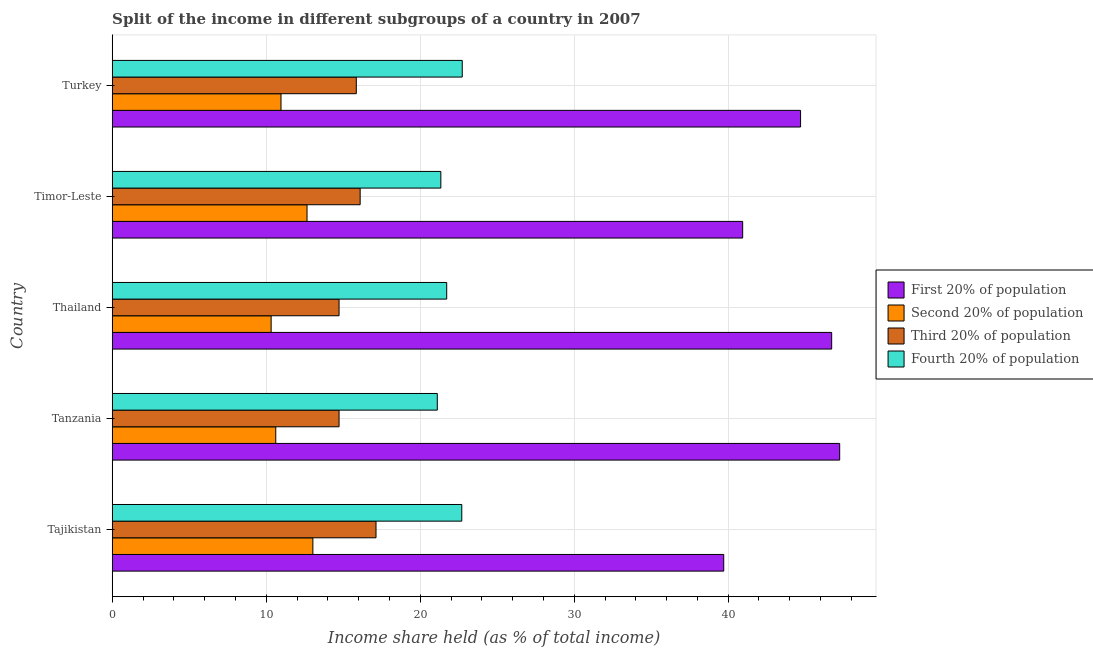Are the number of bars on each tick of the Y-axis equal?
Your response must be concise. Yes. How many bars are there on the 5th tick from the top?
Make the answer very short. 4. How many bars are there on the 1st tick from the bottom?
Ensure brevity in your answer.  4. What is the label of the 2nd group of bars from the top?
Your response must be concise. Timor-Leste. What is the share of the income held by fourth 20% of the population in Turkey?
Your answer should be very brief. 22.73. Across all countries, what is the maximum share of the income held by third 20% of the population?
Give a very brief answer. 17.13. Across all countries, what is the minimum share of the income held by third 20% of the population?
Offer a very short reply. 14.73. In which country was the share of the income held by second 20% of the population maximum?
Your answer should be very brief. Tajikistan. In which country was the share of the income held by second 20% of the population minimum?
Provide a short and direct response. Thailand. What is the total share of the income held by third 20% of the population in the graph?
Make the answer very short. 78.54. What is the difference between the share of the income held by third 20% of the population in Tajikistan and that in Thailand?
Offer a very short reply. 2.4. What is the difference between the share of the income held by second 20% of the population in Turkey and the share of the income held by first 20% of the population in Tajikistan?
Offer a terse response. -28.75. What is the average share of the income held by first 20% of the population per country?
Your answer should be compact. 43.86. What is the difference between the share of the income held by second 20% of the population and share of the income held by fourth 20% of the population in Tajikistan?
Your answer should be compact. -9.67. In how many countries, is the share of the income held by fourth 20% of the population greater than 46 %?
Offer a terse response. 0. What is the ratio of the share of the income held by fourth 20% of the population in Tanzania to that in Turkey?
Your response must be concise. 0.93. Is the difference between the share of the income held by second 20% of the population in Tanzania and Turkey greater than the difference between the share of the income held by third 20% of the population in Tanzania and Turkey?
Give a very brief answer. Yes. What is the difference between the highest and the lowest share of the income held by first 20% of the population?
Offer a terse response. 7.53. In how many countries, is the share of the income held by first 20% of the population greater than the average share of the income held by first 20% of the population taken over all countries?
Offer a very short reply. 3. Is the sum of the share of the income held by third 20% of the population in Tajikistan and Timor-Leste greater than the maximum share of the income held by first 20% of the population across all countries?
Your response must be concise. No. What does the 1st bar from the top in Turkey represents?
Your response must be concise. Fourth 20% of population. What does the 1st bar from the bottom in Thailand represents?
Give a very brief answer. First 20% of population. Is it the case that in every country, the sum of the share of the income held by first 20% of the population and share of the income held by second 20% of the population is greater than the share of the income held by third 20% of the population?
Make the answer very short. Yes. How many bars are there?
Keep it short and to the point. 20. Are all the bars in the graph horizontal?
Provide a short and direct response. Yes. What is the difference between two consecutive major ticks on the X-axis?
Offer a very short reply. 10. Are the values on the major ticks of X-axis written in scientific E-notation?
Offer a very short reply. No. How are the legend labels stacked?
Offer a terse response. Vertical. What is the title of the graph?
Your response must be concise. Split of the income in different subgroups of a country in 2007. Does "Italy" appear as one of the legend labels in the graph?
Your response must be concise. No. What is the label or title of the X-axis?
Your answer should be very brief. Income share held (as % of total income). What is the Income share held (as % of total income) of First 20% of population in Tajikistan?
Your answer should be very brief. 39.71. What is the Income share held (as % of total income) of Second 20% of population in Tajikistan?
Give a very brief answer. 13.03. What is the Income share held (as % of total income) of Third 20% of population in Tajikistan?
Make the answer very short. 17.13. What is the Income share held (as % of total income) in Fourth 20% of population in Tajikistan?
Provide a short and direct response. 22.7. What is the Income share held (as % of total income) of First 20% of population in Tanzania?
Give a very brief answer. 47.24. What is the Income share held (as % of total income) in Second 20% of population in Tanzania?
Your answer should be compact. 10.62. What is the Income share held (as % of total income) of Third 20% of population in Tanzania?
Your answer should be very brief. 14.73. What is the Income share held (as % of total income) of Fourth 20% of population in Tanzania?
Keep it short and to the point. 21.11. What is the Income share held (as % of total income) in First 20% of population in Thailand?
Ensure brevity in your answer.  46.72. What is the Income share held (as % of total income) in Second 20% of population in Thailand?
Your answer should be very brief. 10.32. What is the Income share held (as % of total income) of Third 20% of population in Thailand?
Make the answer very short. 14.73. What is the Income share held (as % of total income) of Fourth 20% of population in Thailand?
Offer a very short reply. 21.72. What is the Income share held (as % of total income) in First 20% of population in Timor-Leste?
Your answer should be very brief. 40.94. What is the Income share held (as % of total income) of Second 20% of population in Timor-Leste?
Give a very brief answer. 12.65. What is the Income share held (as % of total income) in Third 20% of population in Timor-Leste?
Provide a short and direct response. 16.1. What is the Income share held (as % of total income) of Fourth 20% of population in Timor-Leste?
Keep it short and to the point. 21.34. What is the Income share held (as % of total income) in First 20% of population in Turkey?
Ensure brevity in your answer.  44.7. What is the Income share held (as % of total income) in Second 20% of population in Turkey?
Offer a very short reply. 10.96. What is the Income share held (as % of total income) of Third 20% of population in Turkey?
Your answer should be compact. 15.85. What is the Income share held (as % of total income) in Fourth 20% of population in Turkey?
Make the answer very short. 22.73. Across all countries, what is the maximum Income share held (as % of total income) of First 20% of population?
Provide a succinct answer. 47.24. Across all countries, what is the maximum Income share held (as % of total income) of Second 20% of population?
Ensure brevity in your answer.  13.03. Across all countries, what is the maximum Income share held (as % of total income) of Third 20% of population?
Your answer should be compact. 17.13. Across all countries, what is the maximum Income share held (as % of total income) of Fourth 20% of population?
Provide a succinct answer. 22.73. Across all countries, what is the minimum Income share held (as % of total income) in First 20% of population?
Give a very brief answer. 39.71. Across all countries, what is the minimum Income share held (as % of total income) of Second 20% of population?
Your answer should be very brief. 10.32. Across all countries, what is the minimum Income share held (as % of total income) in Third 20% of population?
Ensure brevity in your answer.  14.73. Across all countries, what is the minimum Income share held (as % of total income) of Fourth 20% of population?
Provide a short and direct response. 21.11. What is the total Income share held (as % of total income) in First 20% of population in the graph?
Give a very brief answer. 219.31. What is the total Income share held (as % of total income) of Second 20% of population in the graph?
Your response must be concise. 57.58. What is the total Income share held (as % of total income) in Third 20% of population in the graph?
Provide a succinct answer. 78.54. What is the total Income share held (as % of total income) in Fourth 20% of population in the graph?
Offer a terse response. 109.6. What is the difference between the Income share held (as % of total income) in First 20% of population in Tajikistan and that in Tanzania?
Provide a succinct answer. -7.53. What is the difference between the Income share held (as % of total income) in Second 20% of population in Tajikistan and that in Tanzania?
Offer a very short reply. 2.41. What is the difference between the Income share held (as % of total income) in Fourth 20% of population in Tajikistan and that in Tanzania?
Offer a very short reply. 1.59. What is the difference between the Income share held (as % of total income) in First 20% of population in Tajikistan and that in Thailand?
Your answer should be very brief. -7.01. What is the difference between the Income share held (as % of total income) in Second 20% of population in Tajikistan and that in Thailand?
Offer a very short reply. 2.71. What is the difference between the Income share held (as % of total income) of Fourth 20% of population in Tajikistan and that in Thailand?
Your answer should be compact. 0.98. What is the difference between the Income share held (as % of total income) in First 20% of population in Tajikistan and that in Timor-Leste?
Your response must be concise. -1.23. What is the difference between the Income share held (as % of total income) in Second 20% of population in Tajikistan and that in Timor-Leste?
Offer a very short reply. 0.38. What is the difference between the Income share held (as % of total income) of Third 20% of population in Tajikistan and that in Timor-Leste?
Keep it short and to the point. 1.03. What is the difference between the Income share held (as % of total income) of Fourth 20% of population in Tajikistan and that in Timor-Leste?
Provide a succinct answer. 1.36. What is the difference between the Income share held (as % of total income) of First 20% of population in Tajikistan and that in Turkey?
Provide a short and direct response. -4.99. What is the difference between the Income share held (as % of total income) in Second 20% of population in Tajikistan and that in Turkey?
Your answer should be compact. 2.07. What is the difference between the Income share held (as % of total income) of Third 20% of population in Tajikistan and that in Turkey?
Make the answer very short. 1.28. What is the difference between the Income share held (as % of total income) of Fourth 20% of population in Tajikistan and that in Turkey?
Ensure brevity in your answer.  -0.03. What is the difference between the Income share held (as % of total income) of First 20% of population in Tanzania and that in Thailand?
Make the answer very short. 0.52. What is the difference between the Income share held (as % of total income) in Fourth 20% of population in Tanzania and that in Thailand?
Your answer should be compact. -0.61. What is the difference between the Income share held (as % of total income) of Second 20% of population in Tanzania and that in Timor-Leste?
Keep it short and to the point. -2.03. What is the difference between the Income share held (as % of total income) of Third 20% of population in Tanzania and that in Timor-Leste?
Offer a terse response. -1.37. What is the difference between the Income share held (as % of total income) of Fourth 20% of population in Tanzania and that in Timor-Leste?
Provide a succinct answer. -0.23. What is the difference between the Income share held (as % of total income) of First 20% of population in Tanzania and that in Turkey?
Your response must be concise. 2.54. What is the difference between the Income share held (as % of total income) in Second 20% of population in Tanzania and that in Turkey?
Give a very brief answer. -0.34. What is the difference between the Income share held (as % of total income) of Third 20% of population in Tanzania and that in Turkey?
Your answer should be compact. -1.12. What is the difference between the Income share held (as % of total income) of Fourth 20% of population in Tanzania and that in Turkey?
Make the answer very short. -1.62. What is the difference between the Income share held (as % of total income) in First 20% of population in Thailand and that in Timor-Leste?
Provide a succinct answer. 5.78. What is the difference between the Income share held (as % of total income) of Second 20% of population in Thailand and that in Timor-Leste?
Your response must be concise. -2.33. What is the difference between the Income share held (as % of total income) of Third 20% of population in Thailand and that in Timor-Leste?
Give a very brief answer. -1.37. What is the difference between the Income share held (as % of total income) in Fourth 20% of population in Thailand and that in Timor-Leste?
Your response must be concise. 0.38. What is the difference between the Income share held (as % of total income) of First 20% of population in Thailand and that in Turkey?
Ensure brevity in your answer.  2.02. What is the difference between the Income share held (as % of total income) of Second 20% of population in Thailand and that in Turkey?
Your answer should be very brief. -0.64. What is the difference between the Income share held (as % of total income) in Third 20% of population in Thailand and that in Turkey?
Offer a terse response. -1.12. What is the difference between the Income share held (as % of total income) of Fourth 20% of population in Thailand and that in Turkey?
Keep it short and to the point. -1.01. What is the difference between the Income share held (as % of total income) in First 20% of population in Timor-Leste and that in Turkey?
Your response must be concise. -3.76. What is the difference between the Income share held (as % of total income) in Second 20% of population in Timor-Leste and that in Turkey?
Keep it short and to the point. 1.69. What is the difference between the Income share held (as % of total income) in Third 20% of population in Timor-Leste and that in Turkey?
Your response must be concise. 0.25. What is the difference between the Income share held (as % of total income) of Fourth 20% of population in Timor-Leste and that in Turkey?
Offer a terse response. -1.39. What is the difference between the Income share held (as % of total income) of First 20% of population in Tajikistan and the Income share held (as % of total income) of Second 20% of population in Tanzania?
Offer a terse response. 29.09. What is the difference between the Income share held (as % of total income) of First 20% of population in Tajikistan and the Income share held (as % of total income) of Third 20% of population in Tanzania?
Your answer should be very brief. 24.98. What is the difference between the Income share held (as % of total income) in Second 20% of population in Tajikistan and the Income share held (as % of total income) in Third 20% of population in Tanzania?
Your answer should be compact. -1.7. What is the difference between the Income share held (as % of total income) in Second 20% of population in Tajikistan and the Income share held (as % of total income) in Fourth 20% of population in Tanzania?
Your answer should be compact. -8.08. What is the difference between the Income share held (as % of total income) in Third 20% of population in Tajikistan and the Income share held (as % of total income) in Fourth 20% of population in Tanzania?
Offer a terse response. -3.98. What is the difference between the Income share held (as % of total income) in First 20% of population in Tajikistan and the Income share held (as % of total income) in Second 20% of population in Thailand?
Your response must be concise. 29.39. What is the difference between the Income share held (as % of total income) of First 20% of population in Tajikistan and the Income share held (as % of total income) of Third 20% of population in Thailand?
Provide a short and direct response. 24.98. What is the difference between the Income share held (as % of total income) in First 20% of population in Tajikistan and the Income share held (as % of total income) in Fourth 20% of population in Thailand?
Provide a short and direct response. 17.99. What is the difference between the Income share held (as % of total income) of Second 20% of population in Tajikistan and the Income share held (as % of total income) of Fourth 20% of population in Thailand?
Make the answer very short. -8.69. What is the difference between the Income share held (as % of total income) of Third 20% of population in Tajikistan and the Income share held (as % of total income) of Fourth 20% of population in Thailand?
Keep it short and to the point. -4.59. What is the difference between the Income share held (as % of total income) of First 20% of population in Tajikistan and the Income share held (as % of total income) of Second 20% of population in Timor-Leste?
Make the answer very short. 27.06. What is the difference between the Income share held (as % of total income) in First 20% of population in Tajikistan and the Income share held (as % of total income) in Third 20% of population in Timor-Leste?
Provide a succinct answer. 23.61. What is the difference between the Income share held (as % of total income) of First 20% of population in Tajikistan and the Income share held (as % of total income) of Fourth 20% of population in Timor-Leste?
Your response must be concise. 18.37. What is the difference between the Income share held (as % of total income) of Second 20% of population in Tajikistan and the Income share held (as % of total income) of Third 20% of population in Timor-Leste?
Provide a succinct answer. -3.07. What is the difference between the Income share held (as % of total income) in Second 20% of population in Tajikistan and the Income share held (as % of total income) in Fourth 20% of population in Timor-Leste?
Your answer should be compact. -8.31. What is the difference between the Income share held (as % of total income) in Third 20% of population in Tajikistan and the Income share held (as % of total income) in Fourth 20% of population in Timor-Leste?
Keep it short and to the point. -4.21. What is the difference between the Income share held (as % of total income) in First 20% of population in Tajikistan and the Income share held (as % of total income) in Second 20% of population in Turkey?
Give a very brief answer. 28.75. What is the difference between the Income share held (as % of total income) in First 20% of population in Tajikistan and the Income share held (as % of total income) in Third 20% of population in Turkey?
Give a very brief answer. 23.86. What is the difference between the Income share held (as % of total income) in First 20% of population in Tajikistan and the Income share held (as % of total income) in Fourth 20% of population in Turkey?
Your answer should be compact. 16.98. What is the difference between the Income share held (as % of total income) of Second 20% of population in Tajikistan and the Income share held (as % of total income) of Third 20% of population in Turkey?
Make the answer very short. -2.82. What is the difference between the Income share held (as % of total income) of Second 20% of population in Tajikistan and the Income share held (as % of total income) of Fourth 20% of population in Turkey?
Ensure brevity in your answer.  -9.7. What is the difference between the Income share held (as % of total income) in First 20% of population in Tanzania and the Income share held (as % of total income) in Second 20% of population in Thailand?
Your answer should be compact. 36.92. What is the difference between the Income share held (as % of total income) in First 20% of population in Tanzania and the Income share held (as % of total income) in Third 20% of population in Thailand?
Your answer should be very brief. 32.51. What is the difference between the Income share held (as % of total income) of First 20% of population in Tanzania and the Income share held (as % of total income) of Fourth 20% of population in Thailand?
Provide a short and direct response. 25.52. What is the difference between the Income share held (as % of total income) in Second 20% of population in Tanzania and the Income share held (as % of total income) in Third 20% of population in Thailand?
Ensure brevity in your answer.  -4.11. What is the difference between the Income share held (as % of total income) in Third 20% of population in Tanzania and the Income share held (as % of total income) in Fourth 20% of population in Thailand?
Offer a terse response. -6.99. What is the difference between the Income share held (as % of total income) of First 20% of population in Tanzania and the Income share held (as % of total income) of Second 20% of population in Timor-Leste?
Your answer should be compact. 34.59. What is the difference between the Income share held (as % of total income) in First 20% of population in Tanzania and the Income share held (as % of total income) in Third 20% of population in Timor-Leste?
Offer a very short reply. 31.14. What is the difference between the Income share held (as % of total income) of First 20% of population in Tanzania and the Income share held (as % of total income) of Fourth 20% of population in Timor-Leste?
Keep it short and to the point. 25.9. What is the difference between the Income share held (as % of total income) of Second 20% of population in Tanzania and the Income share held (as % of total income) of Third 20% of population in Timor-Leste?
Offer a terse response. -5.48. What is the difference between the Income share held (as % of total income) of Second 20% of population in Tanzania and the Income share held (as % of total income) of Fourth 20% of population in Timor-Leste?
Your answer should be compact. -10.72. What is the difference between the Income share held (as % of total income) in Third 20% of population in Tanzania and the Income share held (as % of total income) in Fourth 20% of population in Timor-Leste?
Ensure brevity in your answer.  -6.61. What is the difference between the Income share held (as % of total income) in First 20% of population in Tanzania and the Income share held (as % of total income) in Second 20% of population in Turkey?
Give a very brief answer. 36.28. What is the difference between the Income share held (as % of total income) of First 20% of population in Tanzania and the Income share held (as % of total income) of Third 20% of population in Turkey?
Offer a terse response. 31.39. What is the difference between the Income share held (as % of total income) of First 20% of population in Tanzania and the Income share held (as % of total income) of Fourth 20% of population in Turkey?
Provide a short and direct response. 24.51. What is the difference between the Income share held (as % of total income) of Second 20% of population in Tanzania and the Income share held (as % of total income) of Third 20% of population in Turkey?
Your response must be concise. -5.23. What is the difference between the Income share held (as % of total income) in Second 20% of population in Tanzania and the Income share held (as % of total income) in Fourth 20% of population in Turkey?
Provide a succinct answer. -12.11. What is the difference between the Income share held (as % of total income) in First 20% of population in Thailand and the Income share held (as % of total income) in Second 20% of population in Timor-Leste?
Your answer should be compact. 34.07. What is the difference between the Income share held (as % of total income) of First 20% of population in Thailand and the Income share held (as % of total income) of Third 20% of population in Timor-Leste?
Your response must be concise. 30.62. What is the difference between the Income share held (as % of total income) in First 20% of population in Thailand and the Income share held (as % of total income) in Fourth 20% of population in Timor-Leste?
Keep it short and to the point. 25.38. What is the difference between the Income share held (as % of total income) in Second 20% of population in Thailand and the Income share held (as % of total income) in Third 20% of population in Timor-Leste?
Offer a terse response. -5.78. What is the difference between the Income share held (as % of total income) of Second 20% of population in Thailand and the Income share held (as % of total income) of Fourth 20% of population in Timor-Leste?
Your response must be concise. -11.02. What is the difference between the Income share held (as % of total income) of Third 20% of population in Thailand and the Income share held (as % of total income) of Fourth 20% of population in Timor-Leste?
Your response must be concise. -6.61. What is the difference between the Income share held (as % of total income) of First 20% of population in Thailand and the Income share held (as % of total income) of Second 20% of population in Turkey?
Keep it short and to the point. 35.76. What is the difference between the Income share held (as % of total income) in First 20% of population in Thailand and the Income share held (as % of total income) in Third 20% of population in Turkey?
Provide a succinct answer. 30.87. What is the difference between the Income share held (as % of total income) in First 20% of population in Thailand and the Income share held (as % of total income) in Fourth 20% of population in Turkey?
Offer a terse response. 23.99. What is the difference between the Income share held (as % of total income) of Second 20% of population in Thailand and the Income share held (as % of total income) of Third 20% of population in Turkey?
Your response must be concise. -5.53. What is the difference between the Income share held (as % of total income) in Second 20% of population in Thailand and the Income share held (as % of total income) in Fourth 20% of population in Turkey?
Offer a terse response. -12.41. What is the difference between the Income share held (as % of total income) of Third 20% of population in Thailand and the Income share held (as % of total income) of Fourth 20% of population in Turkey?
Provide a short and direct response. -8. What is the difference between the Income share held (as % of total income) in First 20% of population in Timor-Leste and the Income share held (as % of total income) in Second 20% of population in Turkey?
Provide a succinct answer. 29.98. What is the difference between the Income share held (as % of total income) in First 20% of population in Timor-Leste and the Income share held (as % of total income) in Third 20% of population in Turkey?
Offer a terse response. 25.09. What is the difference between the Income share held (as % of total income) in First 20% of population in Timor-Leste and the Income share held (as % of total income) in Fourth 20% of population in Turkey?
Your answer should be very brief. 18.21. What is the difference between the Income share held (as % of total income) of Second 20% of population in Timor-Leste and the Income share held (as % of total income) of Third 20% of population in Turkey?
Keep it short and to the point. -3.2. What is the difference between the Income share held (as % of total income) of Second 20% of population in Timor-Leste and the Income share held (as % of total income) of Fourth 20% of population in Turkey?
Make the answer very short. -10.08. What is the difference between the Income share held (as % of total income) in Third 20% of population in Timor-Leste and the Income share held (as % of total income) in Fourth 20% of population in Turkey?
Keep it short and to the point. -6.63. What is the average Income share held (as % of total income) in First 20% of population per country?
Keep it short and to the point. 43.86. What is the average Income share held (as % of total income) in Second 20% of population per country?
Offer a very short reply. 11.52. What is the average Income share held (as % of total income) in Third 20% of population per country?
Offer a very short reply. 15.71. What is the average Income share held (as % of total income) of Fourth 20% of population per country?
Give a very brief answer. 21.92. What is the difference between the Income share held (as % of total income) in First 20% of population and Income share held (as % of total income) in Second 20% of population in Tajikistan?
Make the answer very short. 26.68. What is the difference between the Income share held (as % of total income) in First 20% of population and Income share held (as % of total income) in Third 20% of population in Tajikistan?
Your answer should be very brief. 22.58. What is the difference between the Income share held (as % of total income) in First 20% of population and Income share held (as % of total income) in Fourth 20% of population in Tajikistan?
Offer a very short reply. 17.01. What is the difference between the Income share held (as % of total income) in Second 20% of population and Income share held (as % of total income) in Fourth 20% of population in Tajikistan?
Your answer should be compact. -9.67. What is the difference between the Income share held (as % of total income) in Third 20% of population and Income share held (as % of total income) in Fourth 20% of population in Tajikistan?
Keep it short and to the point. -5.57. What is the difference between the Income share held (as % of total income) in First 20% of population and Income share held (as % of total income) in Second 20% of population in Tanzania?
Provide a short and direct response. 36.62. What is the difference between the Income share held (as % of total income) of First 20% of population and Income share held (as % of total income) of Third 20% of population in Tanzania?
Offer a very short reply. 32.51. What is the difference between the Income share held (as % of total income) in First 20% of population and Income share held (as % of total income) in Fourth 20% of population in Tanzania?
Your response must be concise. 26.13. What is the difference between the Income share held (as % of total income) in Second 20% of population and Income share held (as % of total income) in Third 20% of population in Tanzania?
Ensure brevity in your answer.  -4.11. What is the difference between the Income share held (as % of total income) of Second 20% of population and Income share held (as % of total income) of Fourth 20% of population in Tanzania?
Keep it short and to the point. -10.49. What is the difference between the Income share held (as % of total income) in Third 20% of population and Income share held (as % of total income) in Fourth 20% of population in Tanzania?
Offer a very short reply. -6.38. What is the difference between the Income share held (as % of total income) of First 20% of population and Income share held (as % of total income) of Second 20% of population in Thailand?
Ensure brevity in your answer.  36.4. What is the difference between the Income share held (as % of total income) in First 20% of population and Income share held (as % of total income) in Third 20% of population in Thailand?
Give a very brief answer. 31.99. What is the difference between the Income share held (as % of total income) in Second 20% of population and Income share held (as % of total income) in Third 20% of population in Thailand?
Ensure brevity in your answer.  -4.41. What is the difference between the Income share held (as % of total income) of Second 20% of population and Income share held (as % of total income) of Fourth 20% of population in Thailand?
Your response must be concise. -11.4. What is the difference between the Income share held (as % of total income) of Third 20% of population and Income share held (as % of total income) of Fourth 20% of population in Thailand?
Make the answer very short. -6.99. What is the difference between the Income share held (as % of total income) in First 20% of population and Income share held (as % of total income) in Second 20% of population in Timor-Leste?
Offer a very short reply. 28.29. What is the difference between the Income share held (as % of total income) of First 20% of population and Income share held (as % of total income) of Third 20% of population in Timor-Leste?
Keep it short and to the point. 24.84. What is the difference between the Income share held (as % of total income) of First 20% of population and Income share held (as % of total income) of Fourth 20% of population in Timor-Leste?
Ensure brevity in your answer.  19.6. What is the difference between the Income share held (as % of total income) in Second 20% of population and Income share held (as % of total income) in Third 20% of population in Timor-Leste?
Give a very brief answer. -3.45. What is the difference between the Income share held (as % of total income) in Second 20% of population and Income share held (as % of total income) in Fourth 20% of population in Timor-Leste?
Offer a very short reply. -8.69. What is the difference between the Income share held (as % of total income) in Third 20% of population and Income share held (as % of total income) in Fourth 20% of population in Timor-Leste?
Provide a succinct answer. -5.24. What is the difference between the Income share held (as % of total income) in First 20% of population and Income share held (as % of total income) in Second 20% of population in Turkey?
Provide a short and direct response. 33.74. What is the difference between the Income share held (as % of total income) of First 20% of population and Income share held (as % of total income) of Third 20% of population in Turkey?
Make the answer very short. 28.85. What is the difference between the Income share held (as % of total income) in First 20% of population and Income share held (as % of total income) in Fourth 20% of population in Turkey?
Your answer should be compact. 21.97. What is the difference between the Income share held (as % of total income) of Second 20% of population and Income share held (as % of total income) of Third 20% of population in Turkey?
Provide a short and direct response. -4.89. What is the difference between the Income share held (as % of total income) in Second 20% of population and Income share held (as % of total income) in Fourth 20% of population in Turkey?
Your answer should be very brief. -11.77. What is the difference between the Income share held (as % of total income) in Third 20% of population and Income share held (as % of total income) in Fourth 20% of population in Turkey?
Your answer should be very brief. -6.88. What is the ratio of the Income share held (as % of total income) of First 20% of population in Tajikistan to that in Tanzania?
Give a very brief answer. 0.84. What is the ratio of the Income share held (as % of total income) of Second 20% of population in Tajikistan to that in Tanzania?
Give a very brief answer. 1.23. What is the ratio of the Income share held (as % of total income) in Third 20% of population in Tajikistan to that in Tanzania?
Your answer should be very brief. 1.16. What is the ratio of the Income share held (as % of total income) of Fourth 20% of population in Tajikistan to that in Tanzania?
Provide a short and direct response. 1.08. What is the ratio of the Income share held (as % of total income) in Second 20% of population in Tajikistan to that in Thailand?
Make the answer very short. 1.26. What is the ratio of the Income share held (as % of total income) in Third 20% of population in Tajikistan to that in Thailand?
Ensure brevity in your answer.  1.16. What is the ratio of the Income share held (as % of total income) in Fourth 20% of population in Tajikistan to that in Thailand?
Make the answer very short. 1.05. What is the ratio of the Income share held (as % of total income) in First 20% of population in Tajikistan to that in Timor-Leste?
Offer a terse response. 0.97. What is the ratio of the Income share held (as % of total income) of Second 20% of population in Tajikistan to that in Timor-Leste?
Offer a very short reply. 1.03. What is the ratio of the Income share held (as % of total income) of Third 20% of population in Tajikistan to that in Timor-Leste?
Provide a succinct answer. 1.06. What is the ratio of the Income share held (as % of total income) in Fourth 20% of population in Tajikistan to that in Timor-Leste?
Your response must be concise. 1.06. What is the ratio of the Income share held (as % of total income) in First 20% of population in Tajikistan to that in Turkey?
Offer a very short reply. 0.89. What is the ratio of the Income share held (as % of total income) in Second 20% of population in Tajikistan to that in Turkey?
Ensure brevity in your answer.  1.19. What is the ratio of the Income share held (as % of total income) of Third 20% of population in Tajikistan to that in Turkey?
Ensure brevity in your answer.  1.08. What is the ratio of the Income share held (as % of total income) of First 20% of population in Tanzania to that in Thailand?
Your response must be concise. 1.01. What is the ratio of the Income share held (as % of total income) in Second 20% of population in Tanzania to that in Thailand?
Give a very brief answer. 1.03. What is the ratio of the Income share held (as % of total income) in Third 20% of population in Tanzania to that in Thailand?
Give a very brief answer. 1. What is the ratio of the Income share held (as % of total income) in Fourth 20% of population in Tanzania to that in Thailand?
Offer a very short reply. 0.97. What is the ratio of the Income share held (as % of total income) in First 20% of population in Tanzania to that in Timor-Leste?
Provide a short and direct response. 1.15. What is the ratio of the Income share held (as % of total income) of Second 20% of population in Tanzania to that in Timor-Leste?
Provide a short and direct response. 0.84. What is the ratio of the Income share held (as % of total income) of Third 20% of population in Tanzania to that in Timor-Leste?
Give a very brief answer. 0.91. What is the ratio of the Income share held (as % of total income) of Fourth 20% of population in Tanzania to that in Timor-Leste?
Provide a short and direct response. 0.99. What is the ratio of the Income share held (as % of total income) in First 20% of population in Tanzania to that in Turkey?
Your answer should be compact. 1.06. What is the ratio of the Income share held (as % of total income) of Third 20% of population in Tanzania to that in Turkey?
Offer a very short reply. 0.93. What is the ratio of the Income share held (as % of total income) of Fourth 20% of population in Tanzania to that in Turkey?
Your answer should be very brief. 0.93. What is the ratio of the Income share held (as % of total income) in First 20% of population in Thailand to that in Timor-Leste?
Provide a succinct answer. 1.14. What is the ratio of the Income share held (as % of total income) of Second 20% of population in Thailand to that in Timor-Leste?
Offer a terse response. 0.82. What is the ratio of the Income share held (as % of total income) of Third 20% of population in Thailand to that in Timor-Leste?
Make the answer very short. 0.91. What is the ratio of the Income share held (as % of total income) in Fourth 20% of population in Thailand to that in Timor-Leste?
Provide a short and direct response. 1.02. What is the ratio of the Income share held (as % of total income) in First 20% of population in Thailand to that in Turkey?
Give a very brief answer. 1.05. What is the ratio of the Income share held (as % of total income) of Second 20% of population in Thailand to that in Turkey?
Offer a very short reply. 0.94. What is the ratio of the Income share held (as % of total income) of Third 20% of population in Thailand to that in Turkey?
Your response must be concise. 0.93. What is the ratio of the Income share held (as % of total income) in Fourth 20% of population in Thailand to that in Turkey?
Keep it short and to the point. 0.96. What is the ratio of the Income share held (as % of total income) of First 20% of population in Timor-Leste to that in Turkey?
Your answer should be very brief. 0.92. What is the ratio of the Income share held (as % of total income) of Second 20% of population in Timor-Leste to that in Turkey?
Provide a succinct answer. 1.15. What is the ratio of the Income share held (as % of total income) in Third 20% of population in Timor-Leste to that in Turkey?
Your answer should be compact. 1.02. What is the ratio of the Income share held (as % of total income) of Fourth 20% of population in Timor-Leste to that in Turkey?
Keep it short and to the point. 0.94. What is the difference between the highest and the second highest Income share held (as % of total income) in First 20% of population?
Ensure brevity in your answer.  0.52. What is the difference between the highest and the second highest Income share held (as % of total income) of Second 20% of population?
Your answer should be very brief. 0.38. What is the difference between the highest and the second highest Income share held (as % of total income) in Third 20% of population?
Your answer should be compact. 1.03. What is the difference between the highest and the lowest Income share held (as % of total income) in First 20% of population?
Offer a very short reply. 7.53. What is the difference between the highest and the lowest Income share held (as % of total income) of Second 20% of population?
Your response must be concise. 2.71. What is the difference between the highest and the lowest Income share held (as % of total income) in Third 20% of population?
Your response must be concise. 2.4. What is the difference between the highest and the lowest Income share held (as % of total income) of Fourth 20% of population?
Offer a very short reply. 1.62. 